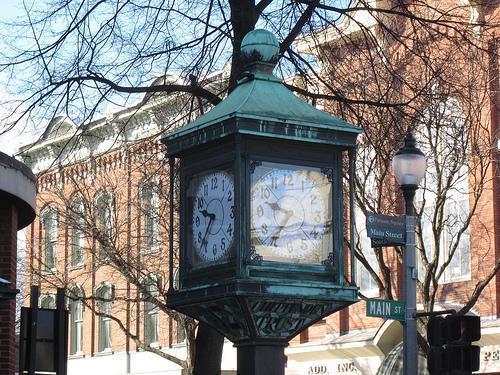How many clocks are in this photograph?
Give a very brief answer. 2. How many people are in this photograph?
Give a very brief answer. 0. 